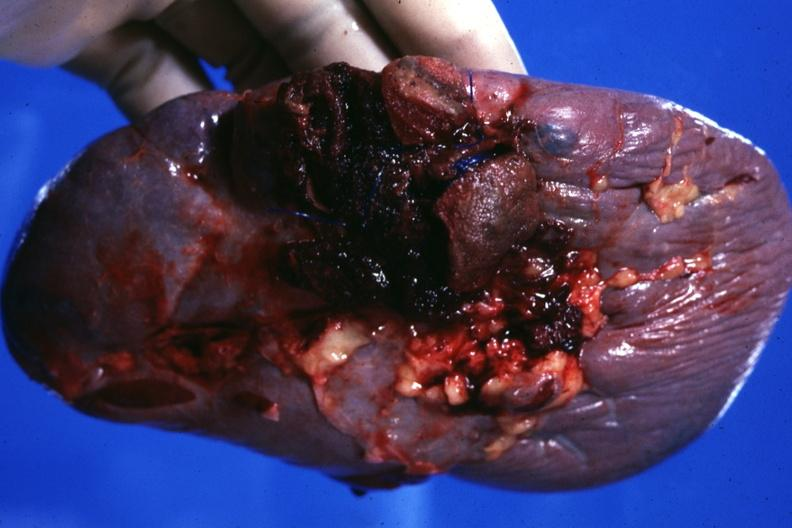s traumatic rupture present?
Answer the question using a single word or phrase. Yes 